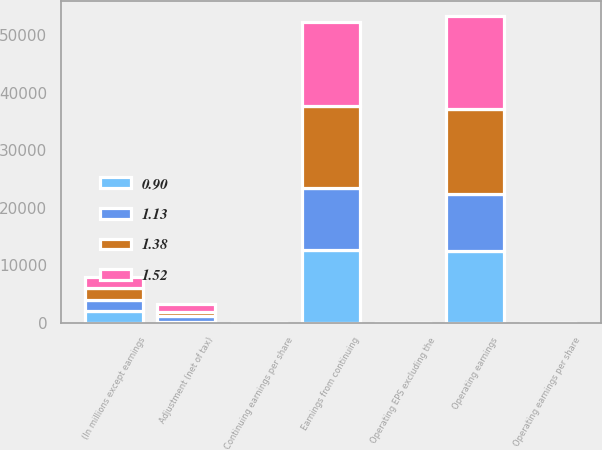<chart> <loc_0><loc_0><loc_500><loc_500><stacked_bar_chart><ecel><fcel>(In millions except earnings<fcel>Earnings from continuing<fcel>Adjustment (net of tax)<fcel>Operating earnings<fcel>Continuing earnings per share<fcel>Operating earnings per share<fcel>Operating EPS excluding the<nl><fcel>1.52<fcel>2012<fcel>14679<fcel>1386<fcel>16065<fcel>1.39<fcel>1.52<fcel>1.52<nl><fcel>1.38<fcel>2011<fcel>14227<fcel>688<fcel>14915<fcel>1.24<fcel>1.31<fcel>1.38<nl><fcel>0.9<fcel>2010<fcel>12613<fcel>205<fcel>12408<fcel>1.15<fcel>1.13<fcel>1.13<nl><fcel>1.13<fcel>2009<fcel>10881<fcel>967<fcel>9914<fcel>0.99<fcel>0.9<fcel>0.9<nl></chart> 